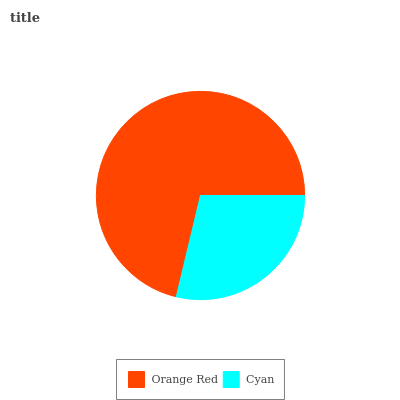Is Cyan the minimum?
Answer yes or no. Yes. Is Orange Red the maximum?
Answer yes or no. Yes. Is Cyan the maximum?
Answer yes or no. No. Is Orange Red greater than Cyan?
Answer yes or no. Yes. Is Cyan less than Orange Red?
Answer yes or no. Yes. Is Cyan greater than Orange Red?
Answer yes or no. No. Is Orange Red less than Cyan?
Answer yes or no. No. Is Orange Red the high median?
Answer yes or no. Yes. Is Cyan the low median?
Answer yes or no. Yes. Is Cyan the high median?
Answer yes or no. No. Is Orange Red the low median?
Answer yes or no. No. 